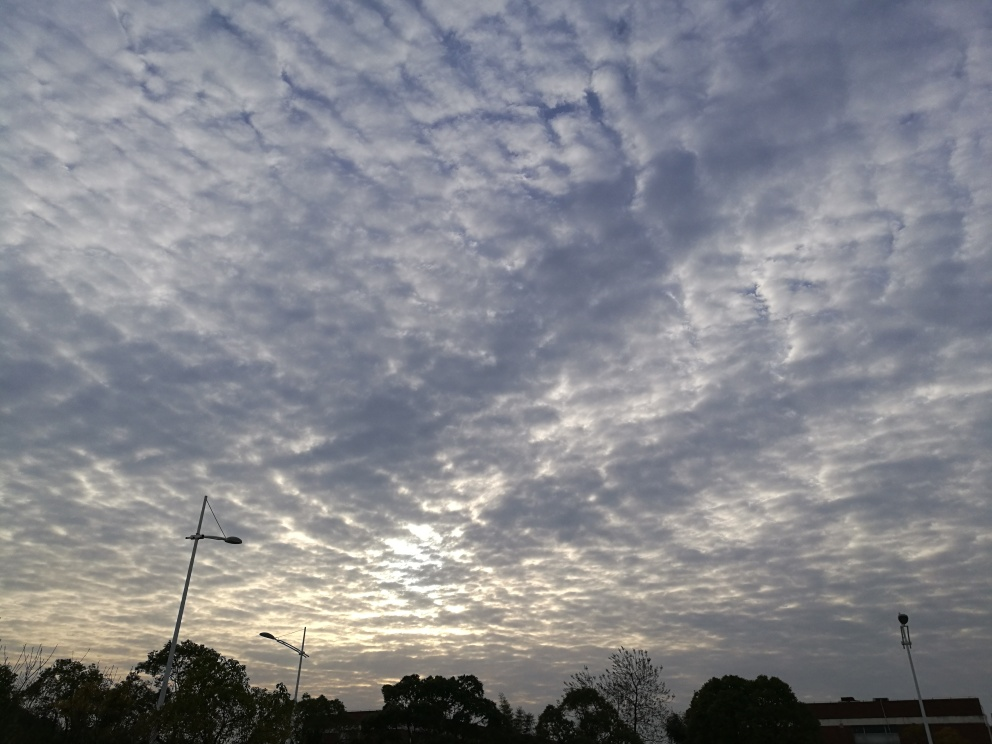Could you describe the weather conditions in this image? The sky is covered with altocumulus clouds, typically associated with stable weather but can precede a storm. The absence of darker, more ominous clouds suggests the weather is likely calm at the time the image was taken. 